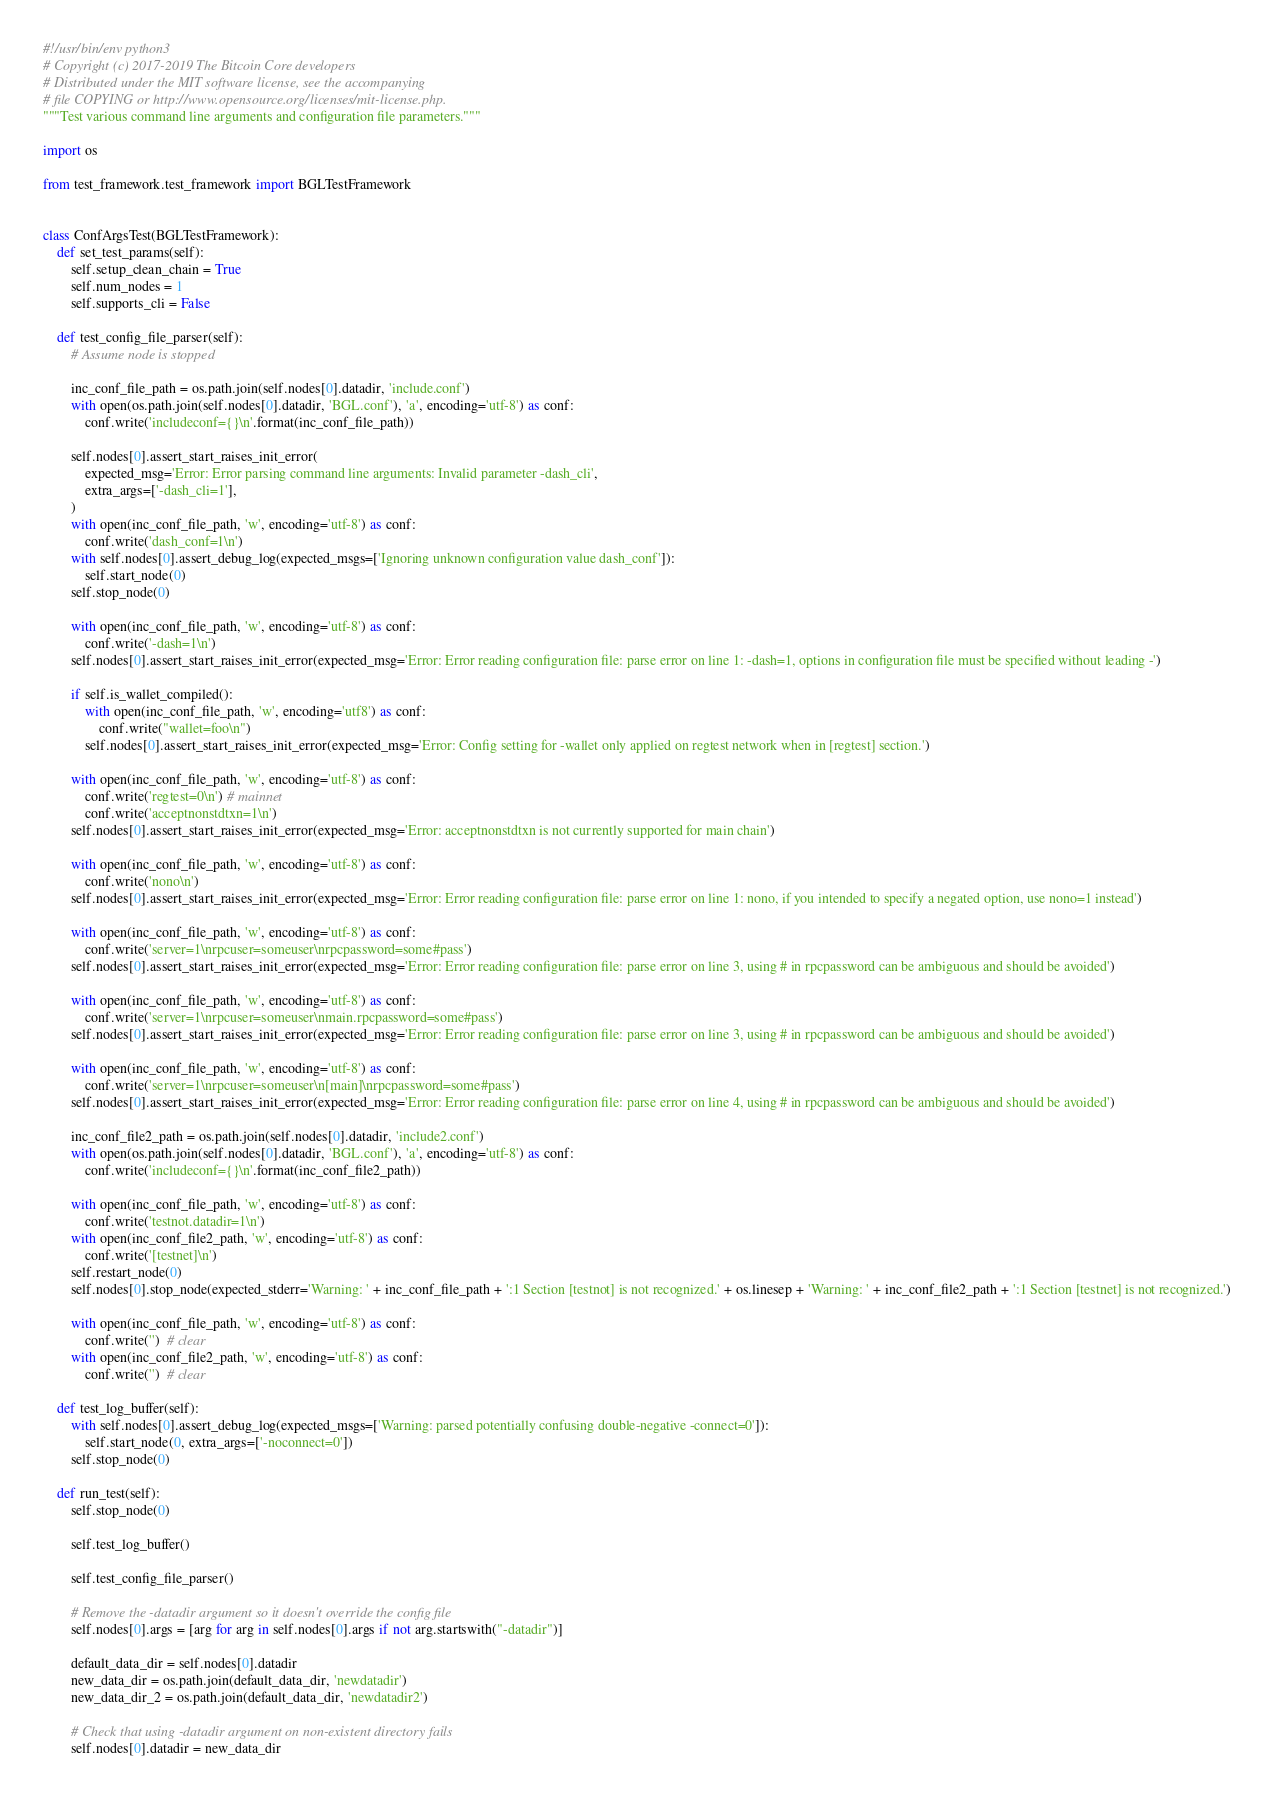<code> <loc_0><loc_0><loc_500><loc_500><_Python_>#!/usr/bin/env python3
# Copyright (c) 2017-2019 The Bitcoin Core developers
# Distributed under the MIT software license, see the accompanying
# file COPYING or http://www.opensource.org/licenses/mit-license.php.
"""Test various command line arguments and configuration file parameters."""

import os

from test_framework.test_framework import BGLTestFramework


class ConfArgsTest(BGLTestFramework):
    def set_test_params(self):
        self.setup_clean_chain = True
        self.num_nodes = 1
        self.supports_cli = False

    def test_config_file_parser(self):
        # Assume node is stopped

        inc_conf_file_path = os.path.join(self.nodes[0].datadir, 'include.conf')
        with open(os.path.join(self.nodes[0].datadir, 'BGL.conf'), 'a', encoding='utf-8') as conf:
            conf.write('includeconf={}\n'.format(inc_conf_file_path))

        self.nodes[0].assert_start_raises_init_error(
            expected_msg='Error: Error parsing command line arguments: Invalid parameter -dash_cli',
            extra_args=['-dash_cli=1'],
        )
        with open(inc_conf_file_path, 'w', encoding='utf-8') as conf:
            conf.write('dash_conf=1\n')
        with self.nodes[0].assert_debug_log(expected_msgs=['Ignoring unknown configuration value dash_conf']):
            self.start_node(0)
        self.stop_node(0)

        with open(inc_conf_file_path, 'w', encoding='utf-8') as conf:
            conf.write('-dash=1\n')
        self.nodes[0].assert_start_raises_init_error(expected_msg='Error: Error reading configuration file: parse error on line 1: -dash=1, options in configuration file must be specified without leading -')

        if self.is_wallet_compiled():
            with open(inc_conf_file_path, 'w', encoding='utf8') as conf:
                conf.write("wallet=foo\n")
            self.nodes[0].assert_start_raises_init_error(expected_msg='Error: Config setting for -wallet only applied on regtest network when in [regtest] section.')

        with open(inc_conf_file_path, 'w', encoding='utf-8') as conf:
            conf.write('regtest=0\n') # mainnet
            conf.write('acceptnonstdtxn=1\n')
        self.nodes[0].assert_start_raises_init_error(expected_msg='Error: acceptnonstdtxn is not currently supported for main chain')

        with open(inc_conf_file_path, 'w', encoding='utf-8') as conf:
            conf.write('nono\n')
        self.nodes[0].assert_start_raises_init_error(expected_msg='Error: Error reading configuration file: parse error on line 1: nono, if you intended to specify a negated option, use nono=1 instead')

        with open(inc_conf_file_path, 'w', encoding='utf-8') as conf:
            conf.write('server=1\nrpcuser=someuser\nrpcpassword=some#pass')
        self.nodes[0].assert_start_raises_init_error(expected_msg='Error: Error reading configuration file: parse error on line 3, using # in rpcpassword can be ambiguous and should be avoided')

        with open(inc_conf_file_path, 'w', encoding='utf-8') as conf:
            conf.write('server=1\nrpcuser=someuser\nmain.rpcpassword=some#pass')
        self.nodes[0].assert_start_raises_init_error(expected_msg='Error: Error reading configuration file: parse error on line 3, using # in rpcpassword can be ambiguous and should be avoided')

        with open(inc_conf_file_path, 'w', encoding='utf-8') as conf:
            conf.write('server=1\nrpcuser=someuser\n[main]\nrpcpassword=some#pass')
        self.nodes[0].assert_start_raises_init_error(expected_msg='Error: Error reading configuration file: parse error on line 4, using # in rpcpassword can be ambiguous and should be avoided')

        inc_conf_file2_path = os.path.join(self.nodes[0].datadir, 'include2.conf')
        with open(os.path.join(self.nodes[0].datadir, 'BGL.conf'), 'a', encoding='utf-8') as conf:
            conf.write('includeconf={}\n'.format(inc_conf_file2_path))

        with open(inc_conf_file_path, 'w', encoding='utf-8') as conf:
            conf.write('testnot.datadir=1\n')
        with open(inc_conf_file2_path, 'w', encoding='utf-8') as conf:
            conf.write('[testnet]\n')
        self.restart_node(0)
        self.nodes[0].stop_node(expected_stderr='Warning: ' + inc_conf_file_path + ':1 Section [testnot] is not recognized.' + os.linesep + 'Warning: ' + inc_conf_file2_path + ':1 Section [testnet] is not recognized.')

        with open(inc_conf_file_path, 'w', encoding='utf-8') as conf:
            conf.write('')  # clear
        with open(inc_conf_file2_path, 'w', encoding='utf-8') as conf:
            conf.write('')  # clear

    def test_log_buffer(self):
        with self.nodes[0].assert_debug_log(expected_msgs=['Warning: parsed potentially confusing double-negative -connect=0']):
            self.start_node(0, extra_args=['-noconnect=0'])
        self.stop_node(0)

    def run_test(self):
        self.stop_node(0)

        self.test_log_buffer()

        self.test_config_file_parser()

        # Remove the -datadir argument so it doesn't override the config file
        self.nodes[0].args = [arg for arg in self.nodes[0].args if not arg.startswith("-datadir")]

        default_data_dir = self.nodes[0].datadir
        new_data_dir = os.path.join(default_data_dir, 'newdatadir')
        new_data_dir_2 = os.path.join(default_data_dir, 'newdatadir2')

        # Check that using -datadir argument on non-existent directory fails
        self.nodes[0].datadir = new_data_dir</code> 